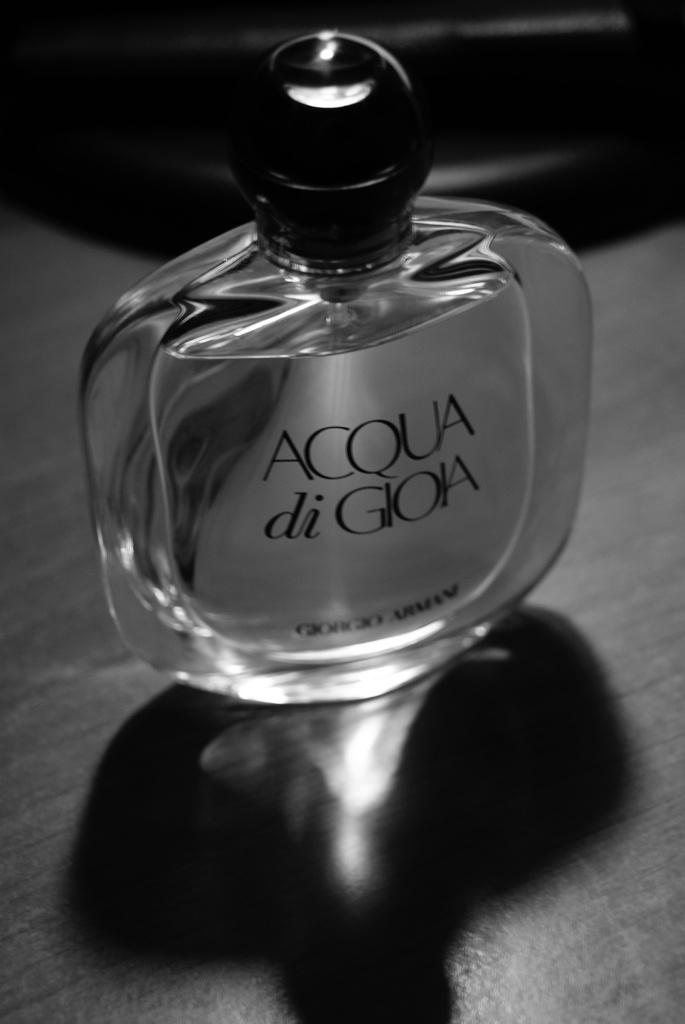<image>
Write a terse but informative summary of the picture. A bottle of Acqua di Gioia perfume by Giorgio Armani. 